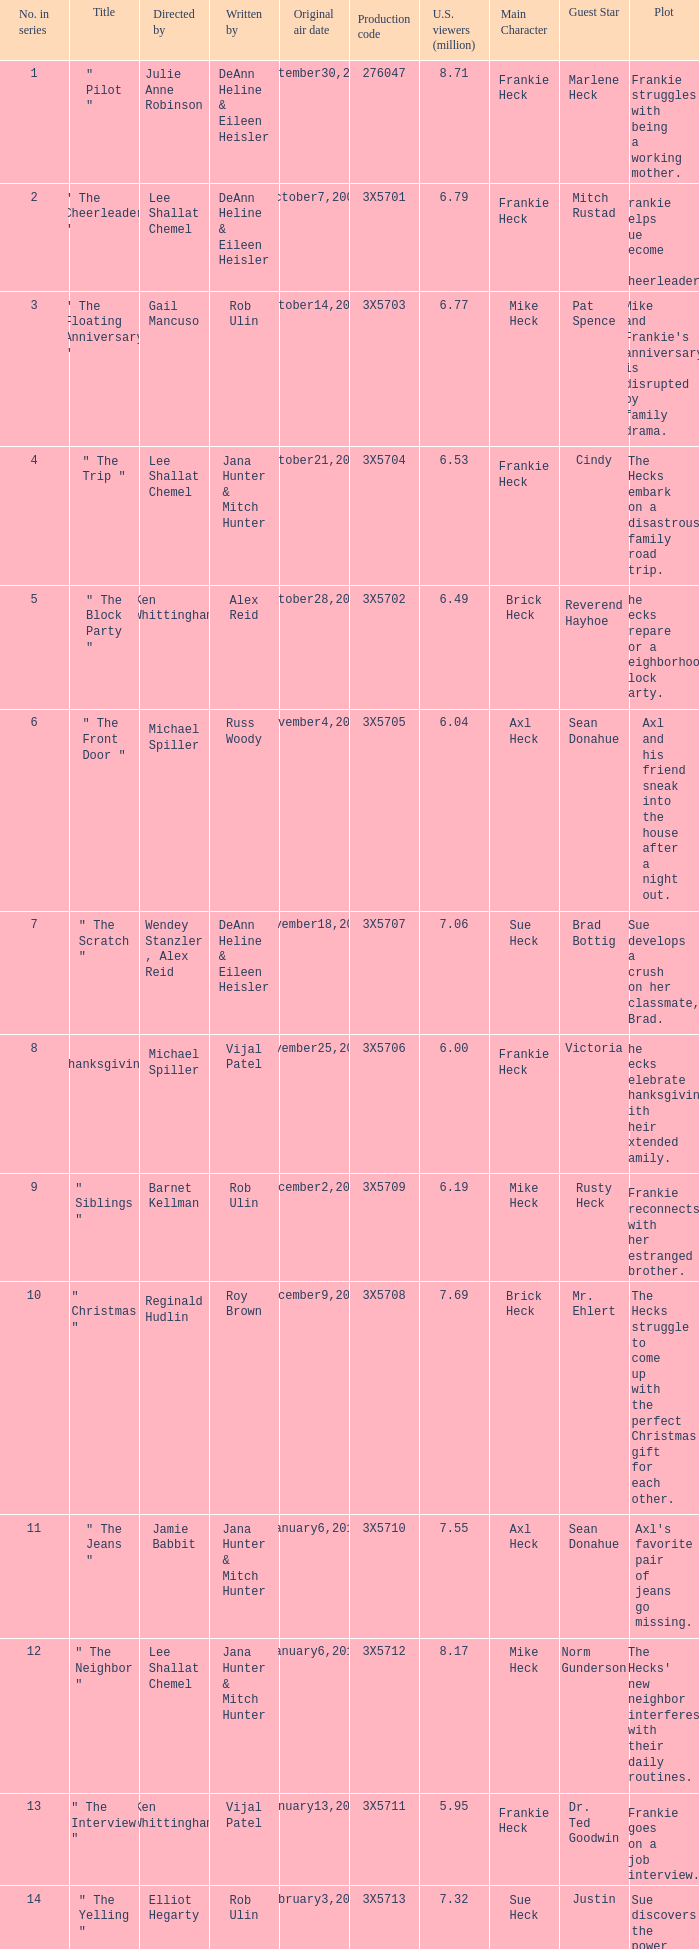How many million U.S. viewers saw the episode with production code 3X5710? 7.55. 